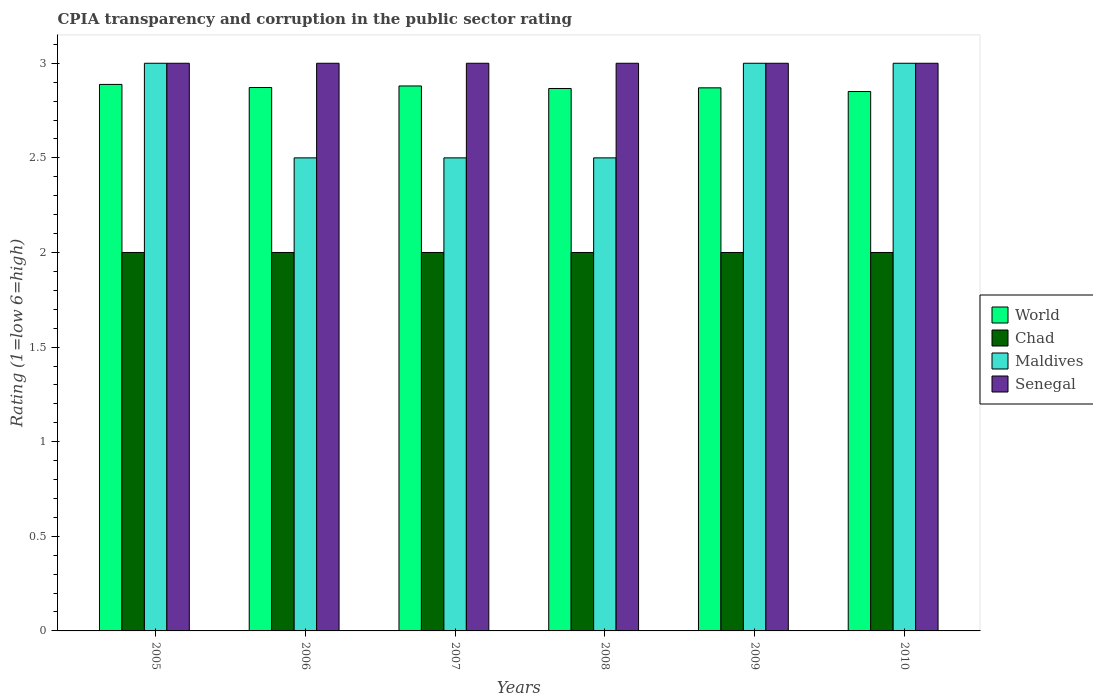Are the number of bars on each tick of the X-axis equal?
Provide a succinct answer. Yes. What is the label of the 4th group of bars from the left?
Your response must be concise. 2008. Across all years, what is the minimum CPIA rating in World?
Make the answer very short. 2.85. In which year was the CPIA rating in Chad maximum?
Offer a very short reply. 2005. In which year was the CPIA rating in Maldives minimum?
Offer a terse response. 2006. What is the difference between the CPIA rating in World in 2005 and that in 2006?
Keep it short and to the point. 0.02. What is the difference between the CPIA rating in World in 2010 and the CPIA rating in Senegal in 2006?
Keep it short and to the point. -0.15. In the year 2005, what is the difference between the CPIA rating in Chad and CPIA rating in World?
Provide a short and direct response. -0.89. What is the ratio of the CPIA rating in Senegal in 2005 to that in 2007?
Offer a terse response. 1. Is the CPIA rating in Maldives in 2007 less than that in 2010?
Offer a terse response. Yes. Is the difference between the CPIA rating in Chad in 2005 and 2006 greater than the difference between the CPIA rating in World in 2005 and 2006?
Give a very brief answer. No. In how many years, is the CPIA rating in Chad greater than the average CPIA rating in Chad taken over all years?
Give a very brief answer. 0. Is the sum of the CPIA rating in Chad in 2007 and 2008 greater than the maximum CPIA rating in Senegal across all years?
Your answer should be very brief. Yes. What does the 4th bar from the left in 2006 represents?
Your answer should be compact. Senegal. What does the 4th bar from the right in 2006 represents?
Provide a succinct answer. World. Are all the bars in the graph horizontal?
Keep it short and to the point. No. How many years are there in the graph?
Your answer should be compact. 6. Does the graph contain grids?
Offer a terse response. No. How many legend labels are there?
Provide a short and direct response. 4. How are the legend labels stacked?
Your answer should be compact. Vertical. What is the title of the graph?
Offer a terse response. CPIA transparency and corruption in the public sector rating. Does "Italy" appear as one of the legend labels in the graph?
Offer a very short reply. No. What is the label or title of the X-axis?
Your response must be concise. Years. What is the Rating (1=low 6=high) in World in 2005?
Your answer should be very brief. 2.89. What is the Rating (1=low 6=high) of Maldives in 2005?
Offer a terse response. 3. What is the Rating (1=low 6=high) of World in 2006?
Provide a short and direct response. 2.87. What is the Rating (1=low 6=high) of Chad in 2006?
Keep it short and to the point. 2. What is the Rating (1=low 6=high) in Senegal in 2006?
Keep it short and to the point. 3. What is the Rating (1=low 6=high) of World in 2007?
Ensure brevity in your answer.  2.88. What is the Rating (1=low 6=high) in Senegal in 2007?
Give a very brief answer. 3. What is the Rating (1=low 6=high) in World in 2008?
Keep it short and to the point. 2.87. What is the Rating (1=low 6=high) in Chad in 2008?
Your answer should be very brief. 2. What is the Rating (1=low 6=high) of Senegal in 2008?
Give a very brief answer. 3. What is the Rating (1=low 6=high) in World in 2009?
Offer a very short reply. 2.87. What is the Rating (1=low 6=high) in Maldives in 2009?
Your answer should be very brief. 3. What is the Rating (1=low 6=high) in World in 2010?
Provide a short and direct response. 2.85. What is the Rating (1=low 6=high) in Chad in 2010?
Give a very brief answer. 2. What is the Rating (1=low 6=high) of Senegal in 2010?
Ensure brevity in your answer.  3. Across all years, what is the maximum Rating (1=low 6=high) in World?
Your answer should be compact. 2.89. Across all years, what is the maximum Rating (1=low 6=high) in Maldives?
Make the answer very short. 3. Across all years, what is the minimum Rating (1=low 6=high) in World?
Ensure brevity in your answer.  2.85. Across all years, what is the minimum Rating (1=low 6=high) of Chad?
Your answer should be very brief. 2. What is the total Rating (1=low 6=high) in World in the graph?
Make the answer very short. 17.23. What is the total Rating (1=low 6=high) in Chad in the graph?
Your answer should be very brief. 12. What is the total Rating (1=low 6=high) of Maldives in the graph?
Provide a succinct answer. 16.5. What is the difference between the Rating (1=low 6=high) of World in 2005 and that in 2006?
Provide a short and direct response. 0.02. What is the difference between the Rating (1=low 6=high) of Senegal in 2005 and that in 2006?
Your answer should be compact. 0. What is the difference between the Rating (1=low 6=high) in World in 2005 and that in 2007?
Keep it short and to the point. 0.01. What is the difference between the Rating (1=low 6=high) in Maldives in 2005 and that in 2007?
Offer a very short reply. 0.5. What is the difference between the Rating (1=low 6=high) of World in 2005 and that in 2008?
Make the answer very short. 0.02. What is the difference between the Rating (1=low 6=high) of Chad in 2005 and that in 2008?
Give a very brief answer. 0. What is the difference between the Rating (1=low 6=high) in Maldives in 2005 and that in 2008?
Provide a short and direct response. 0.5. What is the difference between the Rating (1=low 6=high) of Senegal in 2005 and that in 2008?
Give a very brief answer. 0. What is the difference between the Rating (1=low 6=high) in World in 2005 and that in 2009?
Your answer should be very brief. 0.02. What is the difference between the Rating (1=low 6=high) in Chad in 2005 and that in 2009?
Your answer should be very brief. 0. What is the difference between the Rating (1=low 6=high) of Maldives in 2005 and that in 2009?
Your answer should be very brief. 0. What is the difference between the Rating (1=low 6=high) in World in 2005 and that in 2010?
Ensure brevity in your answer.  0.04. What is the difference between the Rating (1=low 6=high) of Chad in 2005 and that in 2010?
Provide a succinct answer. 0. What is the difference between the Rating (1=low 6=high) of Maldives in 2005 and that in 2010?
Ensure brevity in your answer.  0. What is the difference between the Rating (1=low 6=high) of World in 2006 and that in 2007?
Provide a short and direct response. -0.01. What is the difference between the Rating (1=low 6=high) in Chad in 2006 and that in 2007?
Provide a short and direct response. 0. What is the difference between the Rating (1=low 6=high) of Maldives in 2006 and that in 2007?
Your answer should be compact. 0. What is the difference between the Rating (1=low 6=high) in World in 2006 and that in 2008?
Offer a terse response. 0.01. What is the difference between the Rating (1=low 6=high) of Maldives in 2006 and that in 2008?
Offer a terse response. 0. What is the difference between the Rating (1=low 6=high) in Senegal in 2006 and that in 2008?
Provide a short and direct response. 0. What is the difference between the Rating (1=low 6=high) of World in 2006 and that in 2009?
Offer a terse response. 0. What is the difference between the Rating (1=low 6=high) of Maldives in 2006 and that in 2009?
Your answer should be compact. -0.5. What is the difference between the Rating (1=low 6=high) of Senegal in 2006 and that in 2009?
Provide a succinct answer. 0. What is the difference between the Rating (1=low 6=high) of World in 2006 and that in 2010?
Your answer should be compact. 0.02. What is the difference between the Rating (1=low 6=high) in World in 2007 and that in 2008?
Give a very brief answer. 0.01. What is the difference between the Rating (1=low 6=high) of Maldives in 2007 and that in 2008?
Offer a terse response. 0. What is the difference between the Rating (1=low 6=high) in World in 2007 and that in 2009?
Your answer should be very brief. 0.01. What is the difference between the Rating (1=low 6=high) of Senegal in 2007 and that in 2009?
Your response must be concise. 0. What is the difference between the Rating (1=low 6=high) of World in 2007 and that in 2010?
Your response must be concise. 0.03. What is the difference between the Rating (1=low 6=high) of Chad in 2007 and that in 2010?
Make the answer very short. 0. What is the difference between the Rating (1=low 6=high) of Maldives in 2007 and that in 2010?
Your response must be concise. -0.5. What is the difference between the Rating (1=low 6=high) of Senegal in 2007 and that in 2010?
Provide a succinct answer. 0. What is the difference between the Rating (1=low 6=high) of World in 2008 and that in 2009?
Keep it short and to the point. -0. What is the difference between the Rating (1=low 6=high) in Chad in 2008 and that in 2009?
Provide a short and direct response. 0. What is the difference between the Rating (1=low 6=high) of World in 2008 and that in 2010?
Offer a very short reply. 0.02. What is the difference between the Rating (1=low 6=high) of Maldives in 2008 and that in 2010?
Your answer should be compact. -0.5. What is the difference between the Rating (1=low 6=high) of Senegal in 2008 and that in 2010?
Keep it short and to the point. 0. What is the difference between the Rating (1=low 6=high) in World in 2009 and that in 2010?
Your response must be concise. 0.02. What is the difference between the Rating (1=low 6=high) in World in 2005 and the Rating (1=low 6=high) in Chad in 2006?
Keep it short and to the point. 0.89. What is the difference between the Rating (1=low 6=high) of World in 2005 and the Rating (1=low 6=high) of Maldives in 2006?
Provide a succinct answer. 0.39. What is the difference between the Rating (1=low 6=high) in World in 2005 and the Rating (1=low 6=high) in Senegal in 2006?
Offer a very short reply. -0.11. What is the difference between the Rating (1=low 6=high) of Chad in 2005 and the Rating (1=low 6=high) of Maldives in 2006?
Give a very brief answer. -0.5. What is the difference between the Rating (1=low 6=high) in Chad in 2005 and the Rating (1=low 6=high) in Senegal in 2006?
Provide a succinct answer. -1. What is the difference between the Rating (1=low 6=high) in World in 2005 and the Rating (1=low 6=high) in Chad in 2007?
Your answer should be compact. 0.89. What is the difference between the Rating (1=low 6=high) of World in 2005 and the Rating (1=low 6=high) of Maldives in 2007?
Offer a very short reply. 0.39. What is the difference between the Rating (1=low 6=high) of World in 2005 and the Rating (1=low 6=high) of Senegal in 2007?
Offer a terse response. -0.11. What is the difference between the Rating (1=low 6=high) of Chad in 2005 and the Rating (1=low 6=high) of Maldives in 2007?
Offer a very short reply. -0.5. What is the difference between the Rating (1=low 6=high) of Chad in 2005 and the Rating (1=low 6=high) of Senegal in 2007?
Ensure brevity in your answer.  -1. What is the difference between the Rating (1=low 6=high) of World in 2005 and the Rating (1=low 6=high) of Chad in 2008?
Offer a very short reply. 0.89. What is the difference between the Rating (1=low 6=high) in World in 2005 and the Rating (1=low 6=high) in Maldives in 2008?
Make the answer very short. 0.39. What is the difference between the Rating (1=low 6=high) in World in 2005 and the Rating (1=low 6=high) in Senegal in 2008?
Your response must be concise. -0.11. What is the difference between the Rating (1=low 6=high) of Maldives in 2005 and the Rating (1=low 6=high) of Senegal in 2008?
Keep it short and to the point. 0. What is the difference between the Rating (1=low 6=high) in World in 2005 and the Rating (1=low 6=high) in Chad in 2009?
Ensure brevity in your answer.  0.89. What is the difference between the Rating (1=low 6=high) in World in 2005 and the Rating (1=low 6=high) in Maldives in 2009?
Offer a very short reply. -0.11. What is the difference between the Rating (1=low 6=high) of World in 2005 and the Rating (1=low 6=high) of Senegal in 2009?
Give a very brief answer. -0.11. What is the difference between the Rating (1=low 6=high) in World in 2005 and the Rating (1=low 6=high) in Chad in 2010?
Make the answer very short. 0.89. What is the difference between the Rating (1=low 6=high) in World in 2005 and the Rating (1=low 6=high) in Maldives in 2010?
Your answer should be compact. -0.11. What is the difference between the Rating (1=low 6=high) in World in 2005 and the Rating (1=low 6=high) in Senegal in 2010?
Provide a short and direct response. -0.11. What is the difference between the Rating (1=low 6=high) of World in 2006 and the Rating (1=low 6=high) of Chad in 2007?
Provide a succinct answer. 0.87. What is the difference between the Rating (1=low 6=high) in World in 2006 and the Rating (1=low 6=high) in Maldives in 2007?
Provide a short and direct response. 0.37. What is the difference between the Rating (1=low 6=high) in World in 2006 and the Rating (1=low 6=high) in Senegal in 2007?
Your answer should be very brief. -0.13. What is the difference between the Rating (1=low 6=high) of Chad in 2006 and the Rating (1=low 6=high) of Senegal in 2007?
Provide a succinct answer. -1. What is the difference between the Rating (1=low 6=high) of Maldives in 2006 and the Rating (1=low 6=high) of Senegal in 2007?
Your answer should be compact. -0.5. What is the difference between the Rating (1=low 6=high) of World in 2006 and the Rating (1=low 6=high) of Chad in 2008?
Provide a short and direct response. 0.87. What is the difference between the Rating (1=low 6=high) of World in 2006 and the Rating (1=low 6=high) of Maldives in 2008?
Your response must be concise. 0.37. What is the difference between the Rating (1=low 6=high) of World in 2006 and the Rating (1=low 6=high) of Senegal in 2008?
Give a very brief answer. -0.13. What is the difference between the Rating (1=low 6=high) of Chad in 2006 and the Rating (1=low 6=high) of Maldives in 2008?
Provide a succinct answer. -0.5. What is the difference between the Rating (1=low 6=high) of World in 2006 and the Rating (1=low 6=high) of Chad in 2009?
Ensure brevity in your answer.  0.87. What is the difference between the Rating (1=low 6=high) of World in 2006 and the Rating (1=low 6=high) of Maldives in 2009?
Make the answer very short. -0.13. What is the difference between the Rating (1=low 6=high) of World in 2006 and the Rating (1=low 6=high) of Senegal in 2009?
Make the answer very short. -0.13. What is the difference between the Rating (1=low 6=high) of Chad in 2006 and the Rating (1=low 6=high) of Maldives in 2009?
Give a very brief answer. -1. What is the difference between the Rating (1=low 6=high) of Chad in 2006 and the Rating (1=low 6=high) of Senegal in 2009?
Make the answer very short. -1. What is the difference between the Rating (1=low 6=high) in World in 2006 and the Rating (1=low 6=high) in Chad in 2010?
Your answer should be compact. 0.87. What is the difference between the Rating (1=low 6=high) of World in 2006 and the Rating (1=low 6=high) of Maldives in 2010?
Keep it short and to the point. -0.13. What is the difference between the Rating (1=low 6=high) in World in 2006 and the Rating (1=low 6=high) in Senegal in 2010?
Your answer should be very brief. -0.13. What is the difference between the Rating (1=low 6=high) in Chad in 2006 and the Rating (1=low 6=high) in Maldives in 2010?
Your answer should be compact. -1. What is the difference between the Rating (1=low 6=high) in World in 2007 and the Rating (1=low 6=high) in Chad in 2008?
Provide a succinct answer. 0.88. What is the difference between the Rating (1=low 6=high) of World in 2007 and the Rating (1=low 6=high) of Maldives in 2008?
Your answer should be compact. 0.38. What is the difference between the Rating (1=low 6=high) in World in 2007 and the Rating (1=low 6=high) in Senegal in 2008?
Keep it short and to the point. -0.12. What is the difference between the Rating (1=low 6=high) of Chad in 2007 and the Rating (1=low 6=high) of Senegal in 2008?
Your response must be concise. -1. What is the difference between the Rating (1=low 6=high) of Maldives in 2007 and the Rating (1=low 6=high) of Senegal in 2008?
Offer a very short reply. -0.5. What is the difference between the Rating (1=low 6=high) of World in 2007 and the Rating (1=low 6=high) of Chad in 2009?
Your response must be concise. 0.88. What is the difference between the Rating (1=low 6=high) of World in 2007 and the Rating (1=low 6=high) of Maldives in 2009?
Make the answer very short. -0.12. What is the difference between the Rating (1=low 6=high) in World in 2007 and the Rating (1=low 6=high) in Senegal in 2009?
Keep it short and to the point. -0.12. What is the difference between the Rating (1=low 6=high) in Chad in 2007 and the Rating (1=low 6=high) in Maldives in 2009?
Offer a terse response. -1. What is the difference between the Rating (1=low 6=high) in World in 2007 and the Rating (1=low 6=high) in Maldives in 2010?
Ensure brevity in your answer.  -0.12. What is the difference between the Rating (1=low 6=high) of World in 2007 and the Rating (1=low 6=high) of Senegal in 2010?
Keep it short and to the point. -0.12. What is the difference between the Rating (1=low 6=high) in Maldives in 2007 and the Rating (1=low 6=high) in Senegal in 2010?
Provide a short and direct response. -0.5. What is the difference between the Rating (1=low 6=high) of World in 2008 and the Rating (1=low 6=high) of Chad in 2009?
Provide a short and direct response. 0.87. What is the difference between the Rating (1=low 6=high) of World in 2008 and the Rating (1=low 6=high) of Maldives in 2009?
Offer a terse response. -0.13. What is the difference between the Rating (1=low 6=high) of World in 2008 and the Rating (1=low 6=high) of Senegal in 2009?
Provide a short and direct response. -0.13. What is the difference between the Rating (1=low 6=high) of Chad in 2008 and the Rating (1=low 6=high) of Senegal in 2009?
Ensure brevity in your answer.  -1. What is the difference between the Rating (1=low 6=high) in Maldives in 2008 and the Rating (1=low 6=high) in Senegal in 2009?
Your answer should be compact. -0.5. What is the difference between the Rating (1=low 6=high) in World in 2008 and the Rating (1=low 6=high) in Chad in 2010?
Keep it short and to the point. 0.87. What is the difference between the Rating (1=low 6=high) in World in 2008 and the Rating (1=low 6=high) in Maldives in 2010?
Provide a short and direct response. -0.13. What is the difference between the Rating (1=low 6=high) in World in 2008 and the Rating (1=low 6=high) in Senegal in 2010?
Give a very brief answer. -0.13. What is the difference between the Rating (1=low 6=high) in Chad in 2008 and the Rating (1=low 6=high) in Senegal in 2010?
Provide a short and direct response. -1. What is the difference between the Rating (1=low 6=high) in Maldives in 2008 and the Rating (1=low 6=high) in Senegal in 2010?
Provide a short and direct response. -0.5. What is the difference between the Rating (1=low 6=high) in World in 2009 and the Rating (1=low 6=high) in Chad in 2010?
Provide a succinct answer. 0.87. What is the difference between the Rating (1=low 6=high) in World in 2009 and the Rating (1=low 6=high) in Maldives in 2010?
Offer a terse response. -0.13. What is the difference between the Rating (1=low 6=high) in World in 2009 and the Rating (1=low 6=high) in Senegal in 2010?
Your answer should be very brief. -0.13. What is the average Rating (1=low 6=high) in World per year?
Provide a succinct answer. 2.87. What is the average Rating (1=low 6=high) in Maldives per year?
Offer a very short reply. 2.75. In the year 2005, what is the difference between the Rating (1=low 6=high) of World and Rating (1=low 6=high) of Chad?
Provide a succinct answer. 0.89. In the year 2005, what is the difference between the Rating (1=low 6=high) of World and Rating (1=low 6=high) of Maldives?
Provide a succinct answer. -0.11. In the year 2005, what is the difference between the Rating (1=low 6=high) in World and Rating (1=low 6=high) in Senegal?
Give a very brief answer. -0.11. In the year 2005, what is the difference between the Rating (1=low 6=high) of Chad and Rating (1=low 6=high) of Senegal?
Give a very brief answer. -1. In the year 2005, what is the difference between the Rating (1=low 6=high) of Maldives and Rating (1=low 6=high) of Senegal?
Your response must be concise. 0. In the year 2006, what is the difference between the Rating (1=low 6=high) of World and Rating (1=low 6=high) of Chad?
Offer a very short reply. 0.87. In the year 2006, what is the difference between the Rating (1=low 6=high) of World and Rating (1=low 6=high) of Maldives?
Provide a short and direct response. 0.37. In the year 2006, what is the difference between the Rating (1=low 6=high) in World and Rating (1=low 6=high) in Senegal?
Provide a succinct answer. -0.13. In the year 2006, what is the difference between the Rating (1=low 6=high) in Chad and Rating (1=low 6=high) in Maldives?
Give a very brief answer. -0.5. In the year 2006, what is the difference between the Rating (1=low 6=high) in Chad and Rating (1=low 6=high) in Senegal?
Your answer should be compact. -1. In the year 2006, what is the difference between the Rating (1=low 6=high) of Maldives and Rating (1=low 6=high) of Senegal?
Your answer should be very brief. -0.5. In the year 2007, what is the difference between the Rating (1=low 6=high) of World and Rating (1=low 6=high) of Chad?
Keep it short and to the point. 0.88. In the year 2007, what is the difference between the Rating (1=low 6=high) of World and Rating (1=low 6=high) of Maldives?
Provide a short and direct response. 0.38. In the year 2007, what is the difference between the Rating (1=low 6=high) in World and Rating (1=low 6=high) in Senegal?
Keep it short and to the point. -0.12. In the year 2007, what is the difference between the Rating (1=low 6=high) of Chad and Rating (1=low 6=high) of Maldives?
Ensure brevity in your answer.  -0.5. In the year 2008, what is the difference between the Rating (1=low 6=high) of World and Rating (1=low 6=high) of Chad?
Provide a succinct answer. 0.87. In the year 2008, what is the difference between the Rating (1=low 6=high) in World and Rating (1=low 6=high) in Maldives?
Your response must be concise. 0.37. In the year 2008, what is the difference between the Rating (1=low 6=high) in World and Rating (1=low 6=high) in Senegal?
Offer a terse response. -0.13. In the year 2008, what is the difference between the Rating (1=low 6=high) in Chad and Rating (1=low 6=high) in Senegal?
Ensure brevity in your answer.  -1. In the year 2008, what is the difference between the Rating (1=low 6=high) in Maldives and Rating (1=low 6=high) in Senegal?
Ensure brevity in your answer.  -0.5. In the year 2009, what is the difference between the Rating (1=low 6=high) in World and Rating (1=low 6=high) in Chad?
Make the answer very short. 0.87. In the year 2009, what is the difference between the Rating (1=low 6=high) in World and Rating (1=low 6=high) in Maldives?
Ensure brevity in your answer.  -0.13. In the year 2009, what is the difference between the Rating (1=low 6=high) of World and Rating (1=low 6=high) of Senegal?
Make the answer very short. -0.13. In the year 2009, what is the difference between the Rating (1=low 6=high) in Chad and Rating (1=low 6=high) in Maldives?
Make the answer very short. -1. In the year 2009, what is the difference between the Rating (1=low 6=high) of Chad and Rating (1=low 6=high) of Senegal?
Provide a succinct answer. -1. In the year 2010, what is the difference between the Rating (1=low 6=high) of World and Rating (1=low 6=high) of Chad?
Give a very brief answer. 0.85. In the year 2010, what is the difference between the Rating (1=low 6=high) of World and Rating (1=low 6=high) of Maldives?
Keep it short and to the point. -0.15. In the year 2010, what is the difference between the Rating (1=low 6=high) in World and Rating (1=low 6=high) in Senegal?
Keep it short and to the point. -0.15. What is the ratio of the Rating (1=low 6=high) in Chad in 2005 to that in 2006?
Your answer should be compact. 1. What is the ratio of the Rating (1=low 6=high) of Maldives in 2005 to that in 2006?
Offer a terse response. 1.2. What is the ratio of the Rating (1=low 6=high) in Chad in 2005 to that in 2007?
Provide a succinct answer. 1. What is the ratio of the Rating (1=low 6=high) in Maldives in 2005 to that in 2007?
Your answer should be very brief. 1.2. What is the ratio of the Rating (1=low 6=high) of Senegal in 2005 to that in 2007?
Offer a very short reply. 1. What is the ratio of the Rating (1=low 6=high) of World in 2005 to that in 2008?
Ensure brevity in your answer.  1.01. What is the ratio of the Rating (1=low 6=high) in Chad in 2005 to that in 2008?
Offer a very short reply. 1. What is the ratio of the Rating (1=low 6=high) of Senegal in 2005 to that in 2008?
Keep it short and to the point. 1. What is the ratio of the Rating (1=low 6=high) of World in 2005 to that in 2009?
Make the answer very short. 1.01. What is the ratio of the Rating (1=low 6=high) of Chad in 2005 to that in 2009?
Your answer should be compact. 1. What is the ratio of the Rating (1=low 6=high) in Senegal in 2005 to that in 2009?
Provide a succinct answer. 1. What is the ratio of the Rating (1=low 6=high) in World in 2005 to that in 2010?
Offer a very short reply. 1.01. What is the ratio of the Rating (1=low 6=high) in Maldives in 2005 to that in 2010?
Ensure brevity in your answer.  1. What is the ratio of the Rating (1=low 6=high) in Senegal in 2005 to that in 2010?
Your answer should be very brief. 1. What is the ratio of the Rating (1=low 6=high) of Maldives in 2006 to that in 2007?
Offer a terse response. 1. What is the ratio of the Rating (1=low 6=high) of Chad in 2006 to that in 2009?
Offer a terse response. 1. What is the ratio of the Rating (1=low 6=high) of World in 2006 to that in 2010?
Give a very brief answer. 1.01. What is the ratio of the Rating (1=low 6=high) of World in 2007 to that in 2008?
Your response must be concise. 1. What is the ratio of the Rating (1=low 6=high) of Chad in 2007 to that in 2008?
Your answer should be compact. 1. What is the ratio of the Rating (1=low 6=high) of Senegal in 2007 to that in 2008?
Your response must be concise. 1. What is the ratio of the Rating (1=low 6=high) of Chad in 2007 to that in 2009?
Make the answer very short. 1. What is the ratio of the Rating (1=low 6=high) in Maldives in 2007 to that in 2009?
Make the answer very short. 0.83. What is the ratio of the Rating (1=low 6=high) in World in 2007 to that in 2010?
Your answer should be very brief. 1.01. What is the ratio of the Rating (1=low 6=high) in Chad in 2007 to that in 2010?
Your response must be concise. 1. What is the ratio of the Rating (1=low 6=high) in Maldives in 2007 to that in 2010?
Your answer should be compact. 0.83. What is the ratio of the Rating (1=low 6=high) of Senegal in 2007 to that in 2010?
Keep it short and to the point. 1. What is the ratio of the Rating (1=low 6=high) of World in 2008 to that in 2009?
Your answer should be compact. 1. What is the ratio of the Rating (1=low 6=high) in Maldives in 2008 to that in 2009?
Your response must be concise. 0.83. What is the ratio of the Rating (1=low 6=high) of World in 2008 to that in 2010?
Ensure brevity in your answer.  1.01. What is the ratio of the Rating (1=low 6=high) in Maldives in 2008 to that in 2010?
Give a very brief answer. 0.83. What is the ratio of the Rating (1=low 6=high) in World in 2009 to that in 2010?
Keep it short and to the point. 1.01. What is the ratio of the Rating (1=low 6=high) of Senegal in 2009 to that in 2010?
Keep it short and to the point. 1. What is the difference between the highest and the second highest Rating (1=low 6=high) in World?
Ensure brevity in your answer.  0.01. What is the difference between the highest and the second highest Rating (1=low 6=high) of Chad?
Offer a terse response. 0. What is the difference between the highest and the lowest Rating (1=low 6=high) of World?
Make the answer very short. 0.04. 